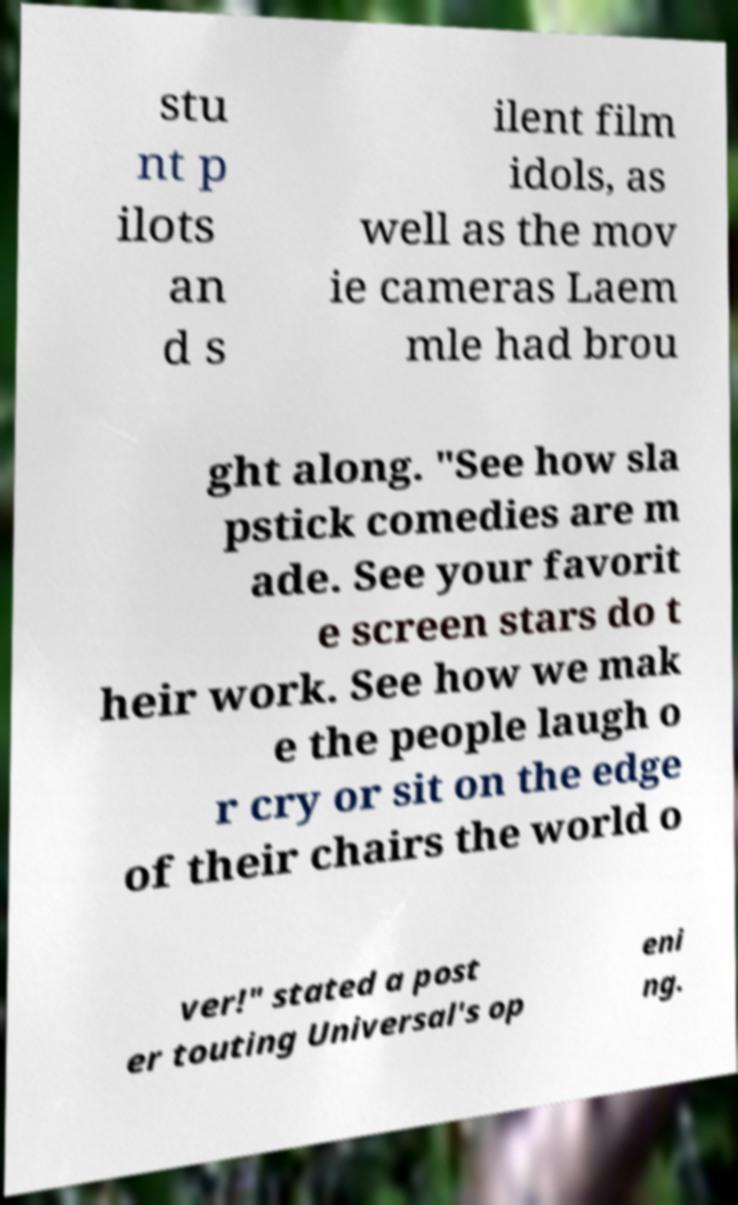Can you accurately transcribe the text from the provided image for me? stu nt p ilots an d s ilent film idols, as well as the mov ie cameras Laem mle had brou ght along. "See how sla pstick comedies are m ade. See your favorit e screen stars do t heir work. See how we mak e the people laugh o r cry or sit on the edge of their chairs the world o ver!" stated a post er touting Universal's op eni ng. 